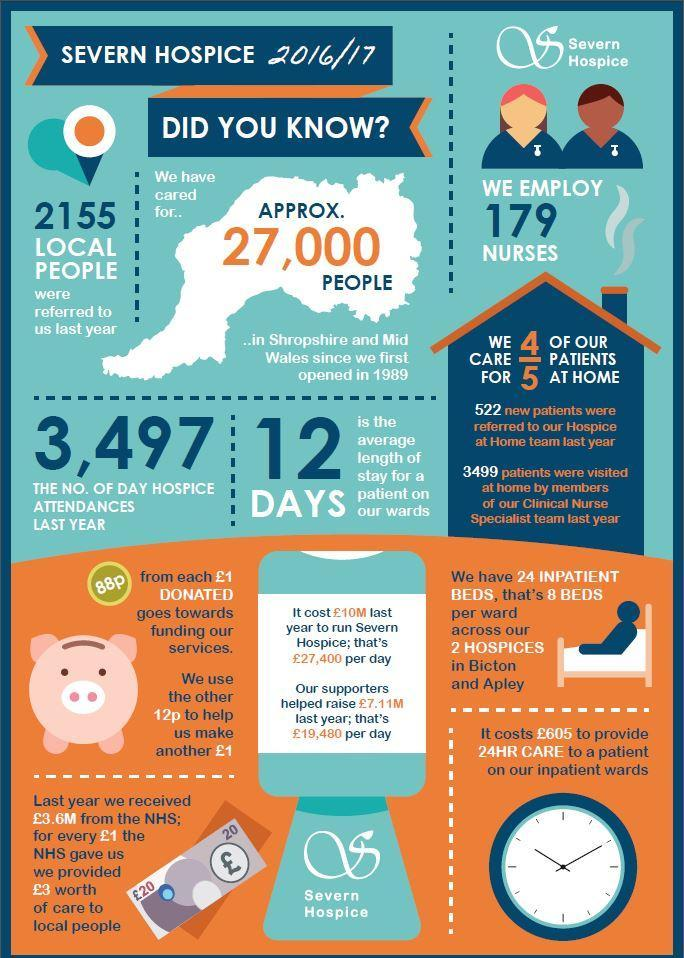How many local people were referred
Answer the question with a short phrase. 2155 How many nurses are employed 179 how many pounds does 24 hr care to a patient in inpatient wards cost 605 what is the cost in pounds to run the hospital per day 27,400 how much goes towards funding the services for every pound donate 88p how many patients are cared at home 4/5 